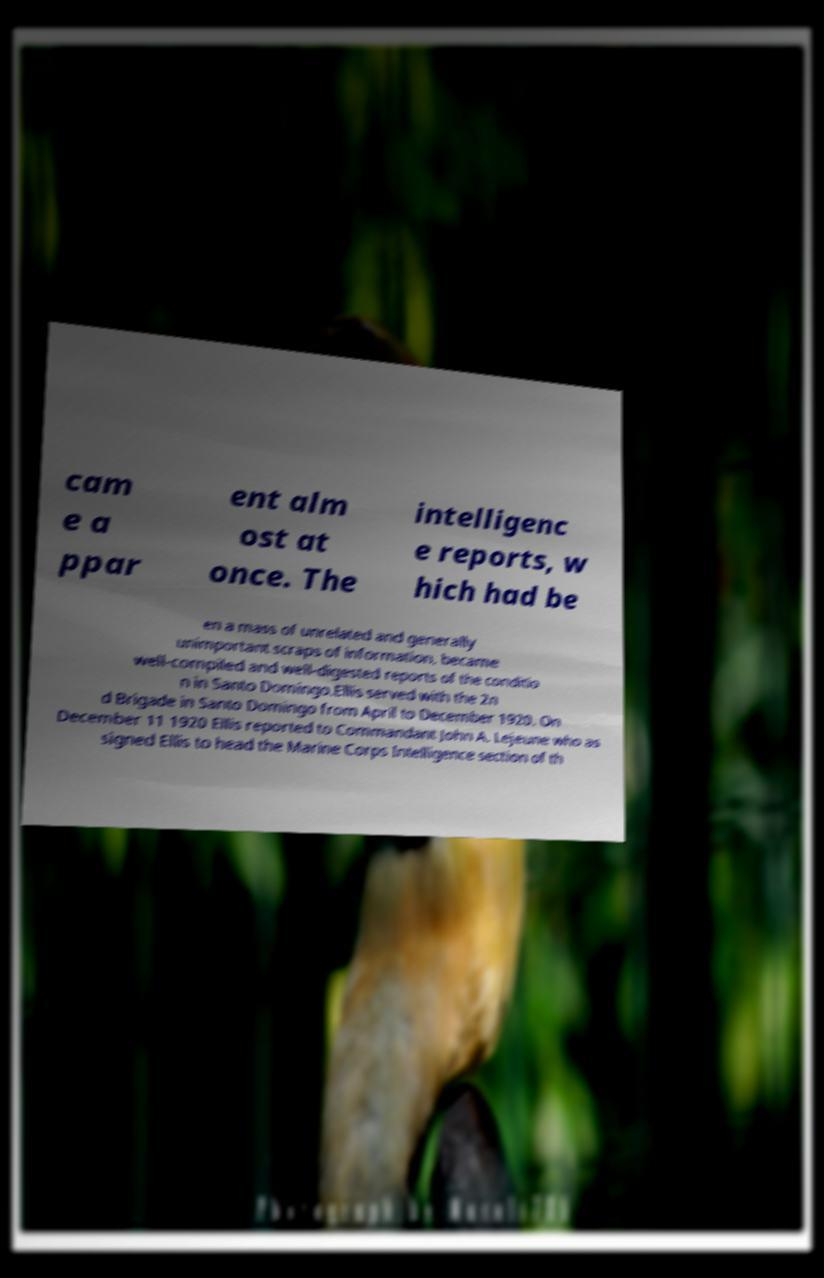Could you extract and type out the text from this image? cam e a ppar ent alm ost at once. The intelligenc e reports, w hich had be en a mass of unrelated and generally unimportant scraps of information, became well-compiled and well-digested reports of the conditio n in Santo Domingo.Ellis served with the 2n d Brigade in Santo Domingo from April to December 1920. On December 11 1920 Ellis reported to Commandant John A. Lejeune who as signed Ellis to head the Marine Corps Intelligence section of th 